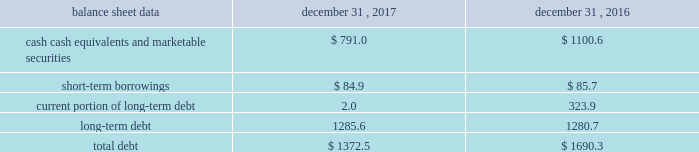Management 2019s discussion and analysis of financial condition and results of operations 2013 ( continued ) ( amounts in millions , except per share amounts ) the effect of foreign exchange rate changes on cash , cash equivalents and restricted cash included in the consolidated statements of cash flows resulted in an increase of $ 11.6 in 2016 , primarily a result of the brazilian real strengthening against the u.s .
Dollar as of december 31 , 2016 compared to december 31 , 2015. .
Liquidity outlook we expect our cash flow from operations and existing cash and cash equivalents to be sufficient to meet our anticipated operating requirements at a minimum for the next twelve months .
We also have a committed corporate credit facility , uncommitted lines of credit and a commercial paper program available to support our operating needs .
We continue to maintain a disciplined approach to managing liquidity , with flexibility over significant uses of cash , including our capital expenditures , cash used for new acquisitions , our common stock repurchase program and our common stock dividends .
From time to time , we evaluate market conditions and financing alternatives for opportunities to raise additional funds or otherwise improve our liquidity profile , enhance our financial flexibility and manage market risk .
Our ability to access the capital markets depends on a number of factors , which include those specific to us , such as our credit ratings , and those related to the financial markets , such as the amount or terms of available credit .
There can be no guarantee that we would be able to access new sources of liquidity , or continue to access existing sources of liquidity , on commercially reasonable terms , or at all .
Funding requirements our most significant funding requirements include our operations , non-cancelable operating lease obligations , capital expenditures , acquisitions , common stock dividends , taxes and debt service .
Additionally , we may be required to make payments to minority shareholders in certain subsidiaries if they exercise their options to sell us their equity interests .
Notable funding requirements include : 2022 debt service 2013 as of december 31 , 2017 , we had outstanding short-term borrowings of $ 84.9 from our uncommitted lines of credit used primarily to fund seasonal working capital needs .
The remainder of our debt is primarily long-term , with maturities scheduled through 2024 .
See the table below for the maturity schedule of our long-term debt .
2022 acquisitions 2013 we paid cash of $ 29.7 , net of cash acquired of $ 7.1 , for acquisitions completed in 2017 .
We also paid $ 0.9 in up-front payments and $ 100.8 in deferred payments for prior-year acquisitions as well as ownership increases in our consolidated subsidiaries .
In addition to potential cash expenditures for new acquisitions , we expect to pay approximately $ 42.0 in 2018 related to prior acquisitions .
We may also be required to pay approximately $ 33.0 in 2018 related to put options held by minority shareholders if exercised .
We will continue to evaluate strategic opportunities to grow and continue to strengthen our market position , particularly in our digital and marketing services offerings , and to expand our presence in high-growth and key strategic world markets .
2022 dividends 2013 during 2017 , we paid four quarterly cash dividends of $ 0.18 per share on our common stock , which corresponded to aggregate dividend payments of $ 280.3 .
On february 14 , 2018 , we announced that our board of directors ( the 201cboard 201d ) had declared a common stock cash dividend of $ 0.21 per share , payable on march 15 , 2018 to holders of record as of the close of business on march 1 , 2018 .
Assuming we pay a quarterly dividend of $ 0.21 per share and there is no significant change in the number of outstanding shares as of december 31 , 2017 , we would expect to pay approximately $ 320.0 over the next twelve months. .
What are the total current liabilities at the end of 2017? 
Computations: (1372.5 - 1285.6)
Answer: 86.9. 